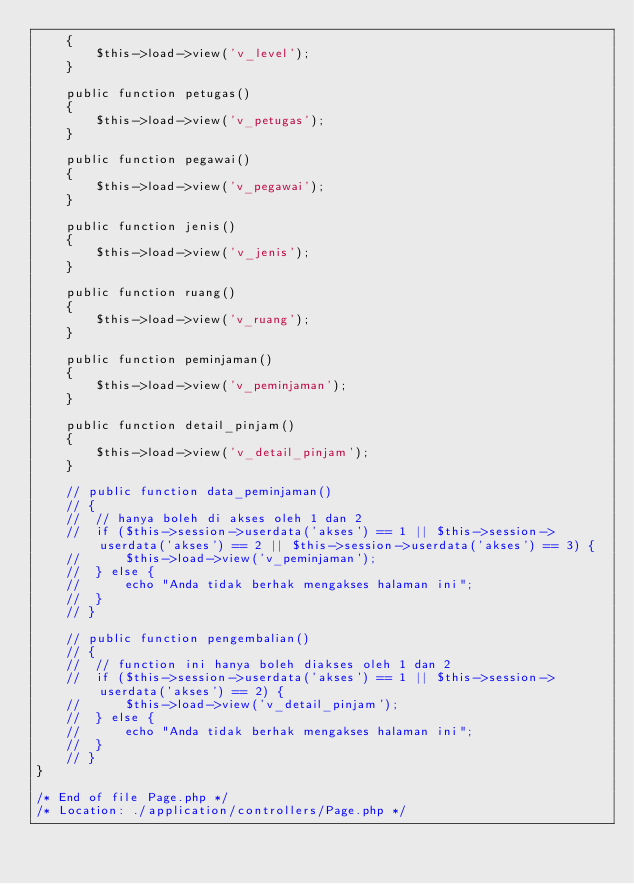Convert code to text. <code><loc_0><loc_0><loc_500><loc_500><_PHP_>	{
		$this->load->view('v_level');
	}

	public function petugas()
	{
		$this->load->view('v_petugas');
	}

	public function pegawai()
	{
		$this->load->view('v_pegawai');
	}

	public function jenis()
	{
		$this->load->view('v_jenis');
	}

	public function ruang()
	{
		$this->load->view('v_ruang');
	}

	public function peminjaman()
	{
		$this->load->view('v_peminjaman');
	}

	public function detail_pinjam()
	{
		$this->load->view('v_detail_pinjam');
	}

	// public function data_peminjaman()
	// {
	// 	// hanya boleh di akses oleh 1 dan 2
	// 	if ($this->session->userdata('akses') == 1 || $this->session->userdata('akses') == 2 || $this->session->userdata('akses') == 3) {
	// 		$this->load->view('v_peminjaman');
	// 	} else {
	// 		echo "Anda tidak berhak mengakses halaman ini";
	// 	}
	// }

	// public function pengembalian()
	// {
	// 	// function ini hanya boleh diakses oleh 1 dan 2
	// 	if ($this->session->userdata('akses') == 1 || $this->session->userdata('akses') == 2) {
	// 		$this->load->view('v_detail_pinjam');
	// 	} else {
	// 		echo "Anda tidak berhak mengakses halaman ini";
	// 	}
	// }
}

/* End of file Page.php */
/* Location: ./application/controllers/Page.php */
</code> 